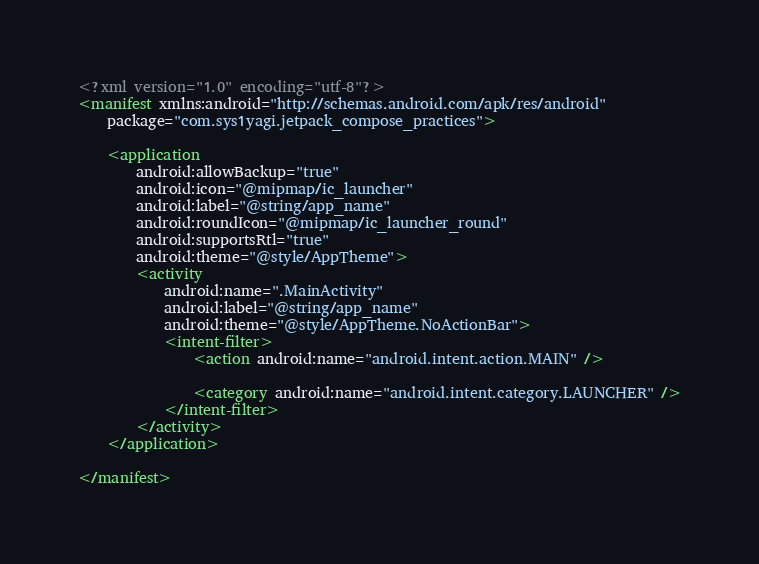<code> <loc_0><loc_0><loc_500><loc_500><_XML_><?xml version="1.0" encoding="utf-8"?>
<manifest xmlns:android="http://schemas.android.com/apk/res/android"
    package="com.sys1yagi.jetpack_compose_practices">

    <application
        android:allowBackup="true"
        android:icon="@mipmap/ic_launcher"
        android:label="@string/app_name"
        android:roundIcon="@mipmap/ic_launcher_round"
        android:supportsRtl="true"
        android:theme="@style/AppTheme">
        <activity
            android:name=".MainActivity"
            android:label="@string/app_name"
            android:theme="@style/AppTheme.NoActionBar">
            <intent-filter>
                <action android:name="android.intent.action.MAIN" />

                <category android:name="android.intent.category.LAUNCHER" />
            </intent-filter>
        </activity>
    </application>

</manifest></code> 